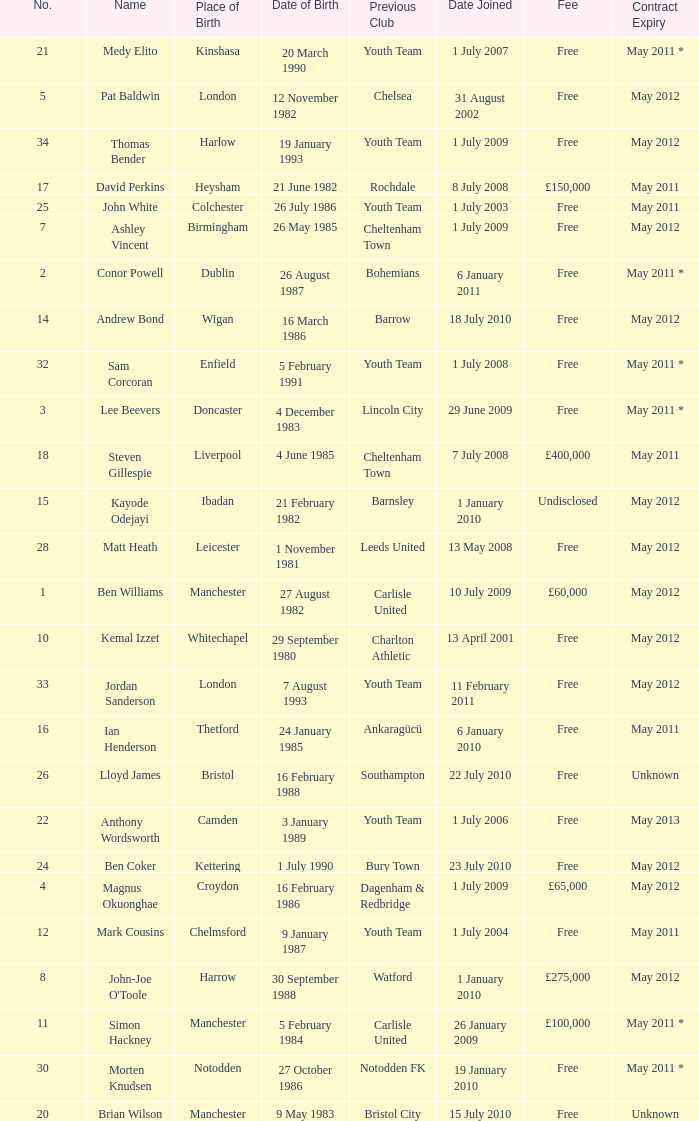For the ben williams name what was the previous club Carlisle United. 